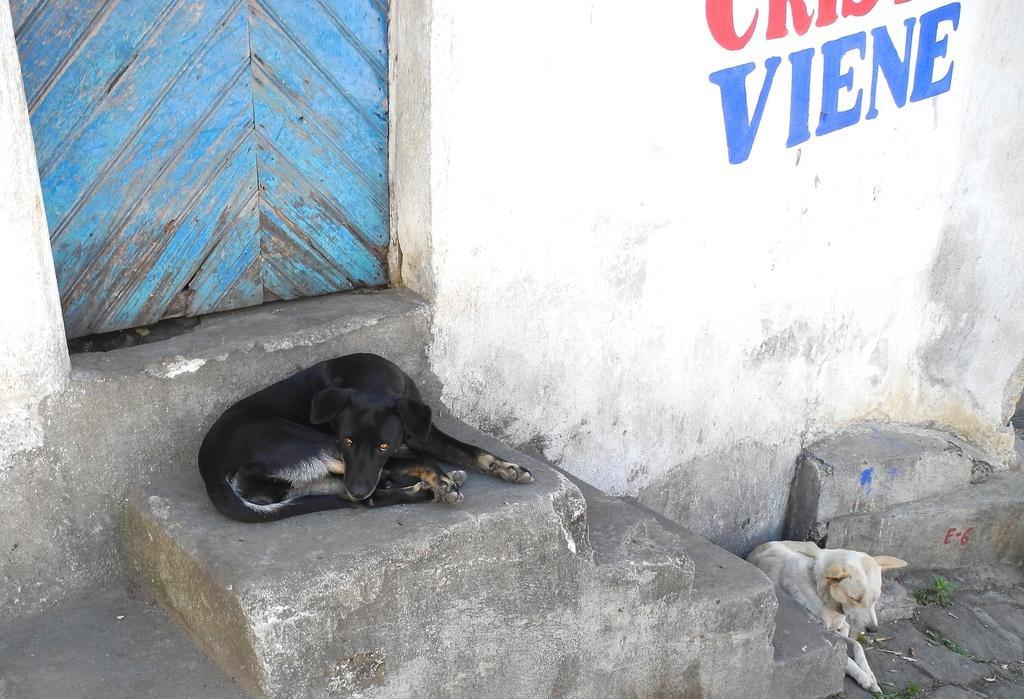Can you describe this image briefly? In this image, in the middle, we can see a dog which is in black color and it is lying on the land. On the right side, we can see a dog which is in white color. In the background, we can see a door which is closed and a wall with some text. On the right side, we can also see a staircase. 